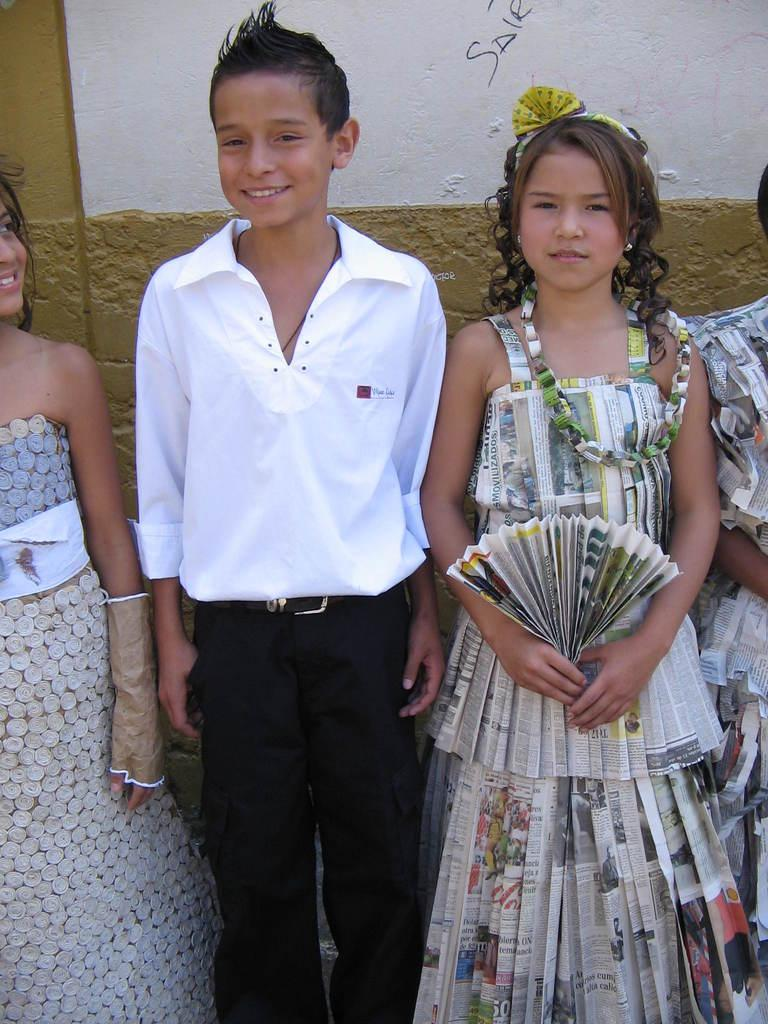How many people are in the image? There are people in the image, but the exact number is not specified. Can you describe the appearance of the people in the image? Two of the people are wearing different costumes. What type of dust can be seen on the pizzas in the image? There is no mention of pizzas or dust in the image, so this question cannot be answered. 